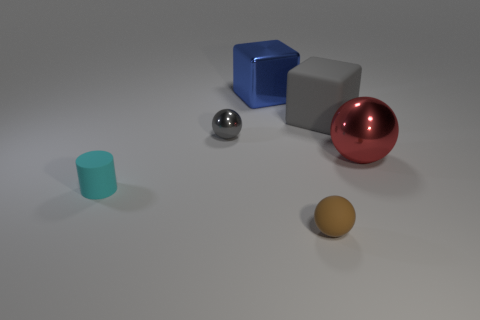Add 3 large yellow rubber cylinders. How many objects exist? 9 Subtract 1 cubes. How many cubes are left? 1 Subtract all cyan spheres. How many gray cubes are left? 1 Subtract all tiny balls. Subtract all matte blocks. How many objects are left? 3 Add 1 small gray spheres. How many small gray spheres are left? 2 Add 1 big metal cubes. How many big metal cubes exist? 2 Subtract all brown balls. How many balls are left? 2 Subtract all metal balls. How many balls are left? 1 Subtract 1 red balls. How many objects are left? 5 Subtract all blocks. How many objects are left? 4 